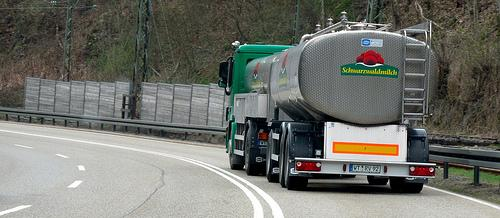Identify the primary object and its action in the image. A truck is driving down a curvy road surrounded by trees and a mountain. Analyze any potential interactions between the objects in the image. The truck may interact with the railing along the road, or drive over the crack in the pavement. What type of road is shown in the image and what is its condition? The image shows an asphalt road with a yellow double line; it has a small crack in the pavement. Explain the sentiment or atmosphere portrayed by the image. The image displays a calm atmosphere, capturing the truck driving peacefully along a scenic road surrounded by nature. Provide a brief description of the scene in the image. The scene shows a semi-truck with a green cab and a Mercedes logo moving along a curved road, with trees and a mountain in the background. Count the number of trees lining the road. There are multiple trees along the road, but an exact count is not provided in the description. Mention two distinct features of the truck in the image. The truck has a green cab and big wheels, and there is a ladder on the tank. What are some safety features visible on the truck in the image? The truck has two red lights, a license plate on the back, and a metal guard rail beside it. Find out any markings or stickers on the tank of the semi-truck. The tank has a blue and white sticker on it, along with yellow lettering on a green background. 